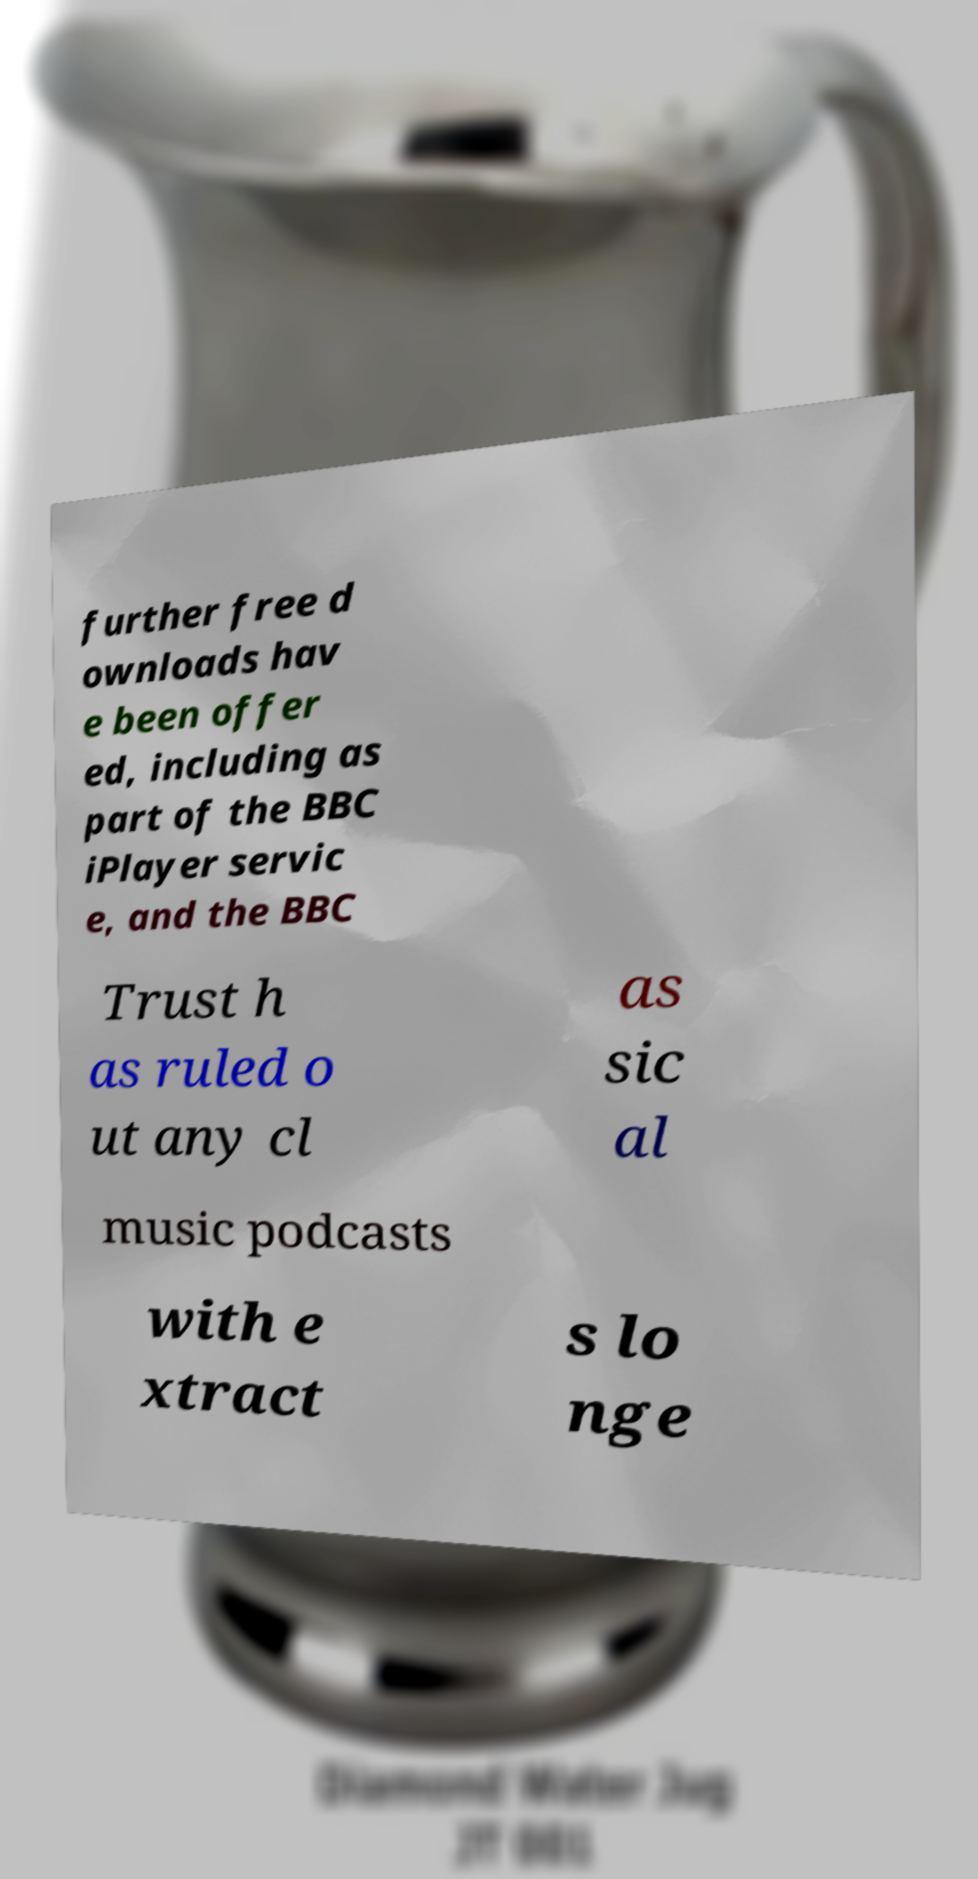Can you accurately transcribe the text from the provided image for me? further free d ownloads hav e been offer ed, including as part of the BBC iPlayer servic e, and the BBC Trust h as ruled o ut any cl as sic al music podcasts with e xtract s lo nge 